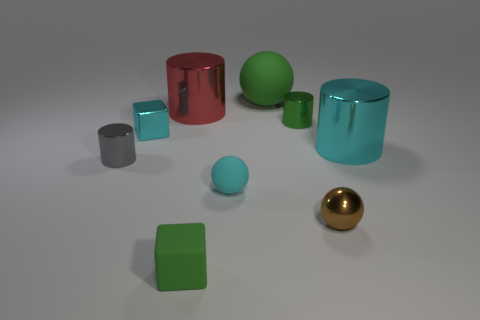Subtract all green cylinders. How many cylinders are left? 3 Subtract all cyan cylinders. How many cylinders are left? 3 Subtract all yellow cylinders. Subtract all gray blocks. How many cylinders are left? 4 Subtract all balls. How many objects are left? 6 Add 6 green matte spheres. How many green matte spheres are left? 7 Add 2 big rubber spheres. How many big rubber spheres exist? 3 Subtract 0 blue spheres. How many objects are left? 9 Subtract all gray cylinders. Subtract all red objects. How many objects are left? 7 